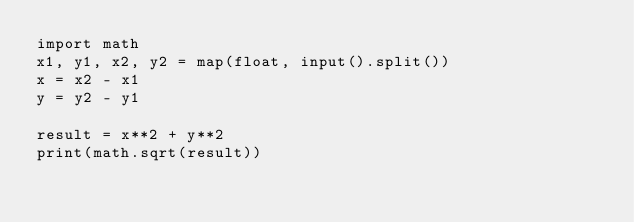Convert code to text. <code><loc_0><loc_0><loc_500><loc_500><_Python_>import math
x1, y1, x2, y2 = map(float, input().split())
x = x2 - x1
y = y2 - y1

result = x**2 + y**2
print(math.sqrt(result))</code> 